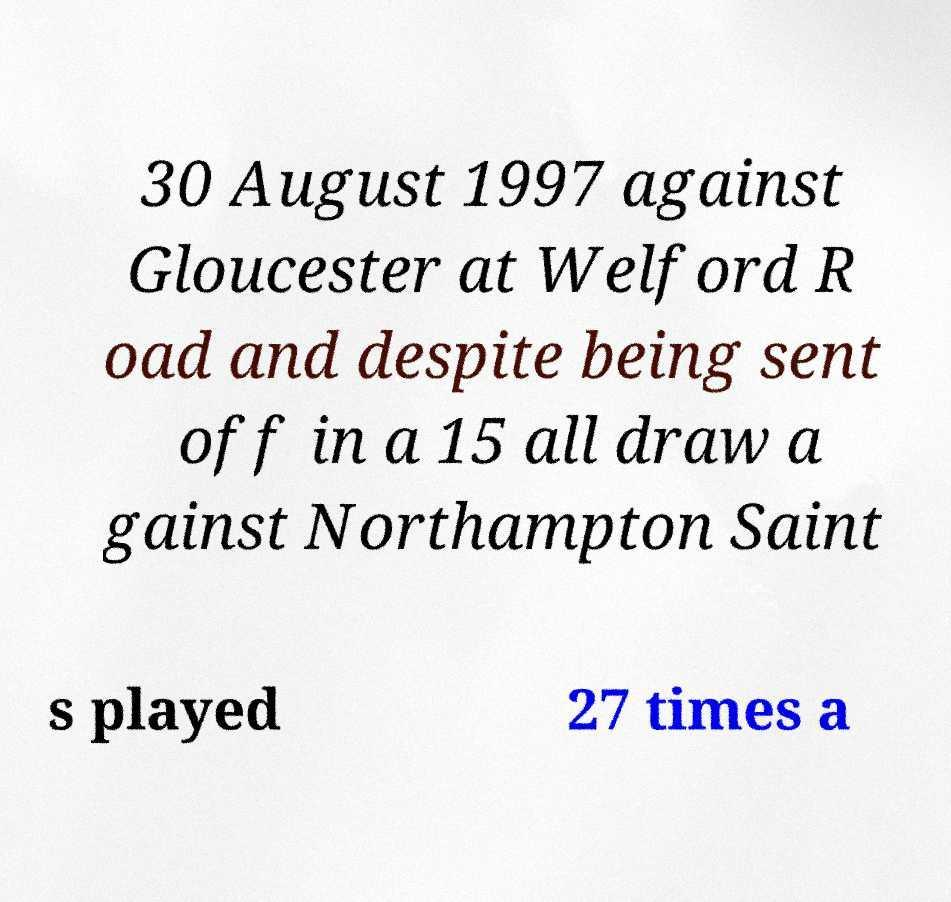Please read and relay the text visible in this image. What does it say? 30 August 1997 against Gloucester at Welford R oad and despite being sent off in a 15 all draw a gainst Northampton Saint s played 27 times a 